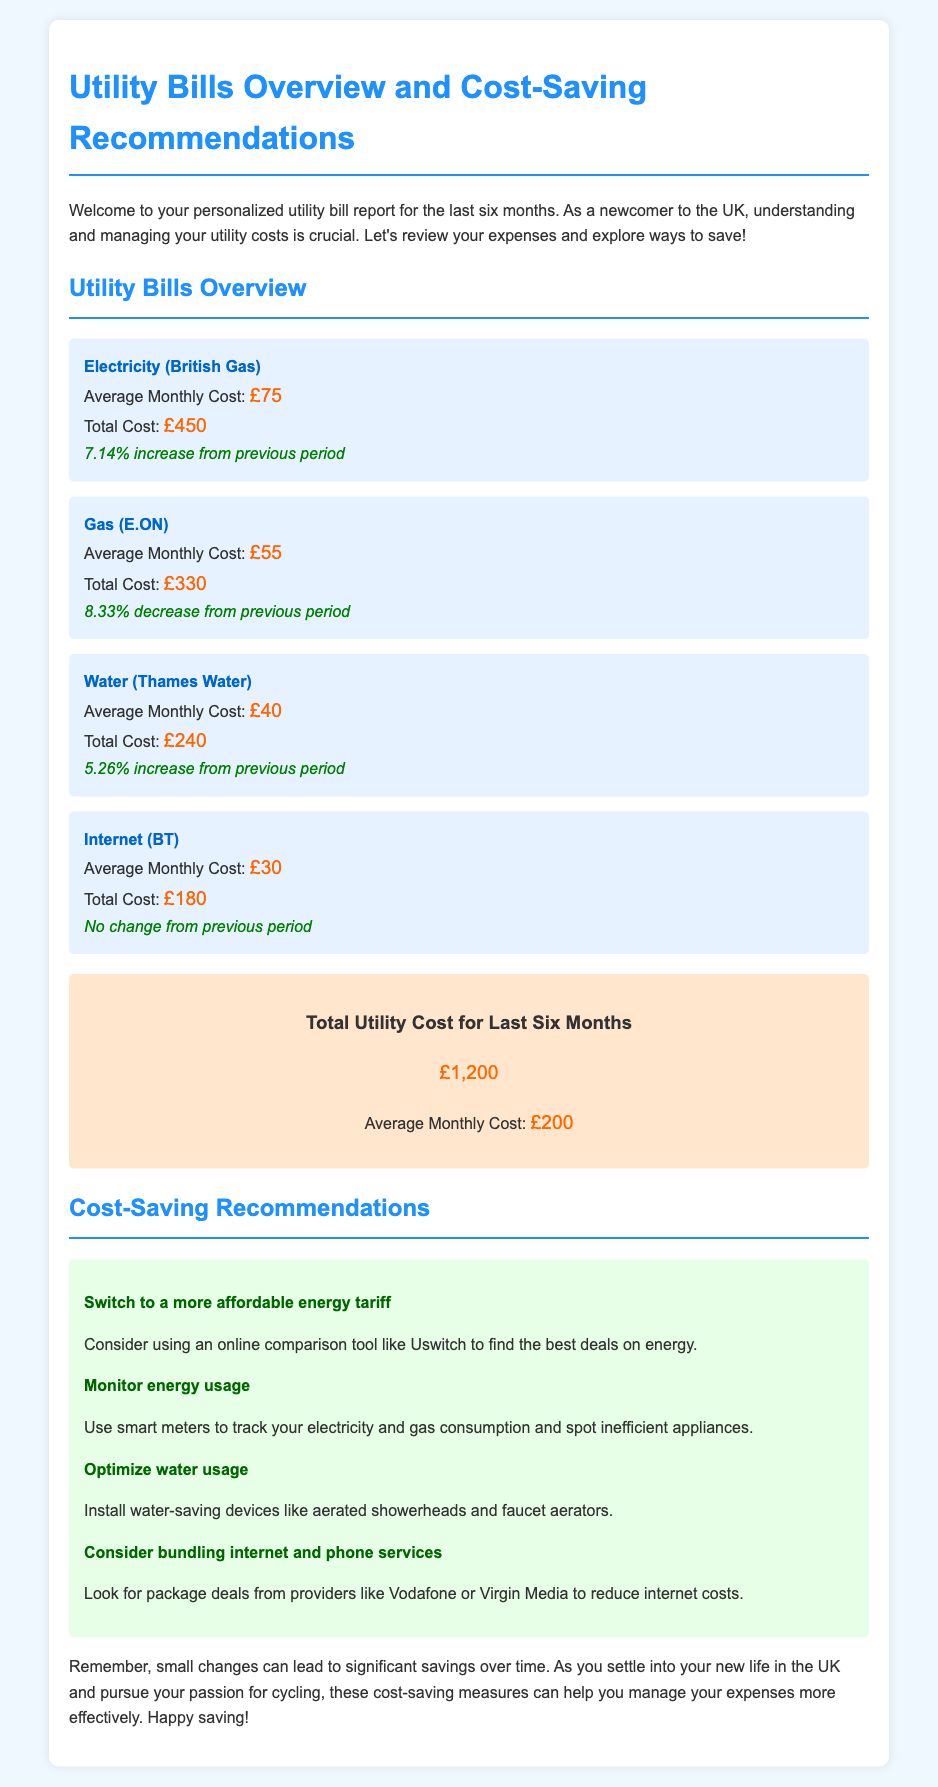What is the average monthly cost of electricity? The average monthly cost of electricity is stated in the utility report, which is £75.
Answer: £75 What is the total cost for gas? The total cost for gas is presented in the report, which amounts to £330.
Answer: £330 What percentage increase did electricity costs see from the previous period? The percentage increase for electricity is highlighted in the document, which is 7.14%.
Answer: 7.14% Which utility has had no change in cost? The utility with no change in cost is specified in the report as internet (BT).
Answer: Internet (BT) What is one recommendation for reducing utility costs? The report offers various recommendations, one of which is to switch to a more affordable energy tariff.
Answer: Switch to a more affordable energy tariff What is the total utility cost for the last six months? The document clearly states the total utility cost for the last six months as £1,200.
Answer: £1,200 What was the average monthly cost for water? The average monthly cost for water is included in the utility overview, which is £40.
Answer: £40 What company provides the internet service? The company providing internet service is mentioned as BT in the report.
Answer: BT 